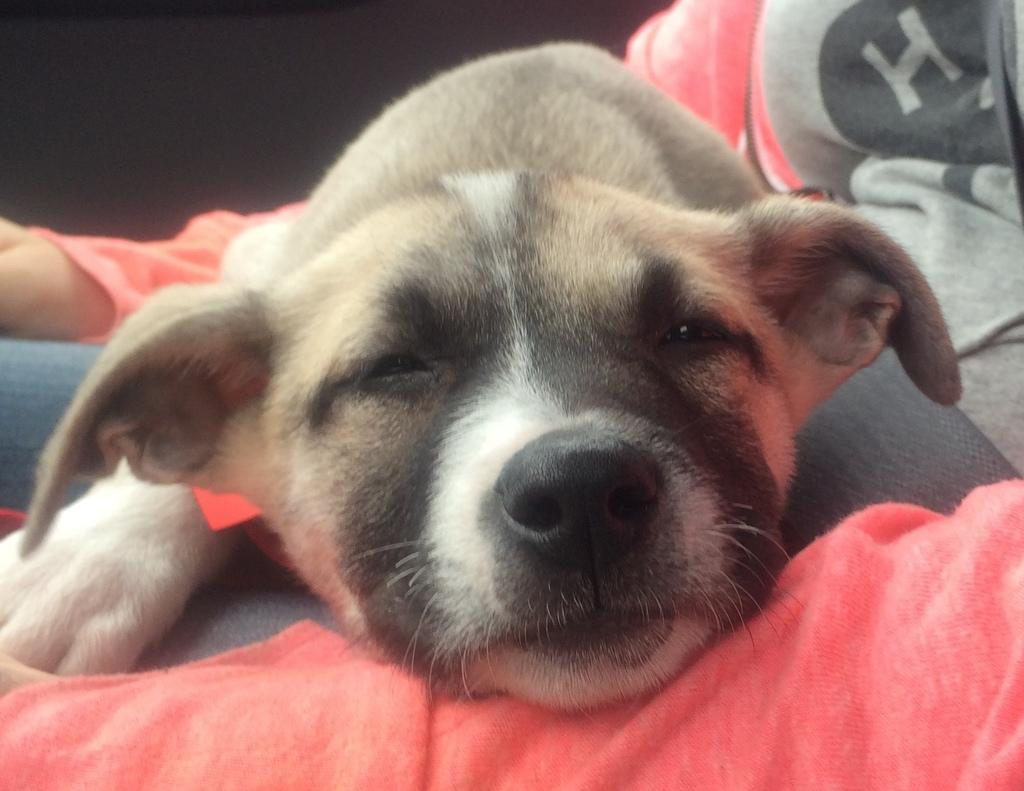What animal can be seen in the picture? There is a dog in the picture. What is the dog doing in the picture? The dog is lying on a person's leg. How is the person dressed in the picture? The person is wearing a red and grey color dress. What type of stocking is the stranger wearing in the sand in the image? There is no stranger or sand present in the image; it features a dog lying on a person's leg, and the person is wearing a red and grey color dress. 